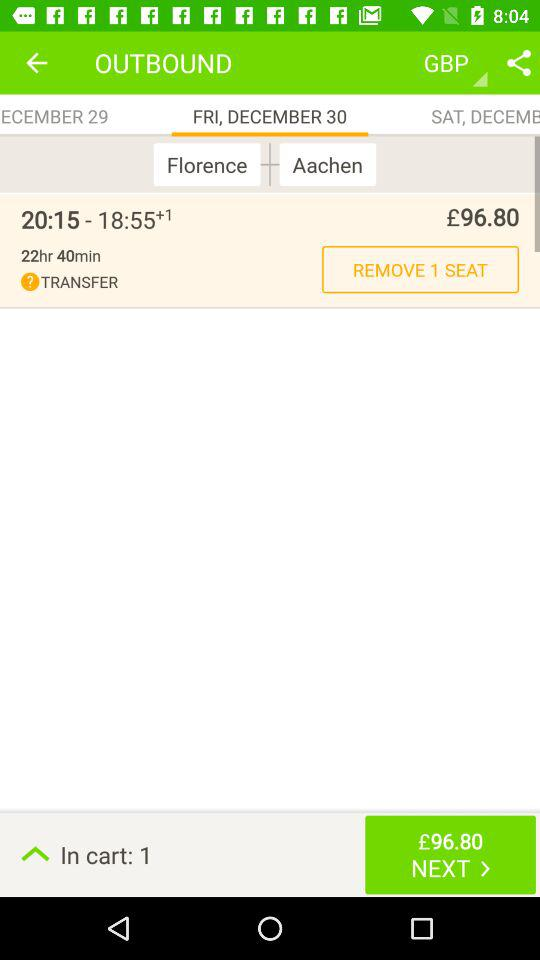How much is the cost of 1 seat? The cost is £96.80. 